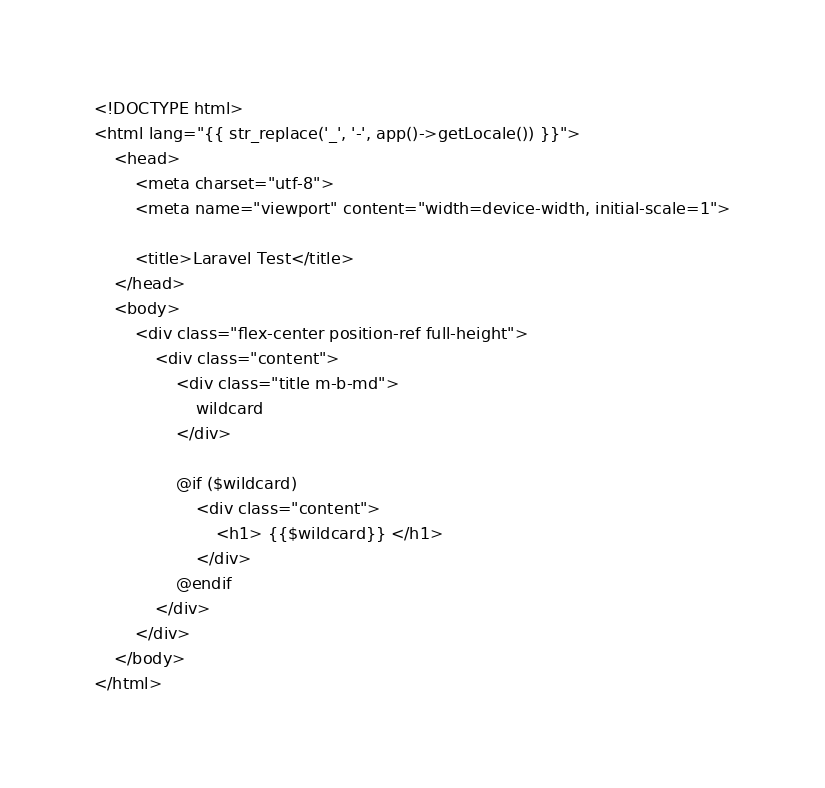Convert code to text. <code><loc_0><loc_0><loc_500><loc_500><_PHP_><!DOCTYPE html>
<html lang="{{ str_replace('_', '-', app()->getLocale()) }}">
    <head>
        <meta charset="utf-8">
        <meta name="viewport" content="width=device-width, initial-scale=1">

        <title>Laravel Test</title>
    </head>
    <body>
        <div class="flex-center position-ref full-height">
            <div class="content">
                <div class="title m-b-md">
                    wildcard
                </div>

                @if ($wildcard)
                    <div class="content">
                        <h1> {{$wildcard}} </h1>
                    </div>
                @endif
            </div>
        </div>
    </body>
</html>
</code> 